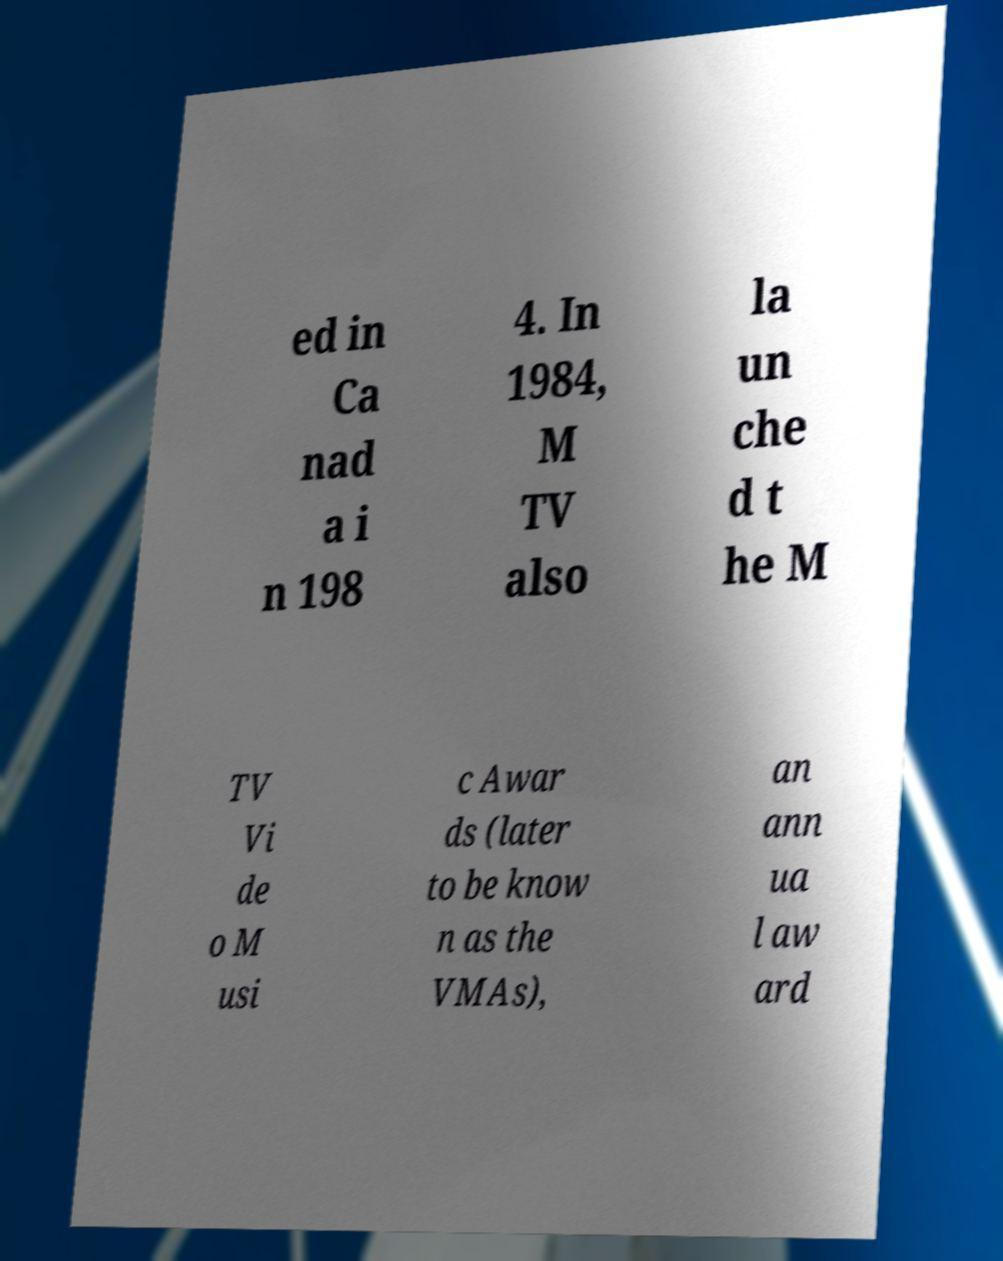Please identify and transcribe the text found in this image. ed in Ca nad a i n 198 4. In 1984, M TV also la un che d t he M TV Vi de o M usi c Awar ds (later to be know n as the VMAs), an ann ua l aw ard 